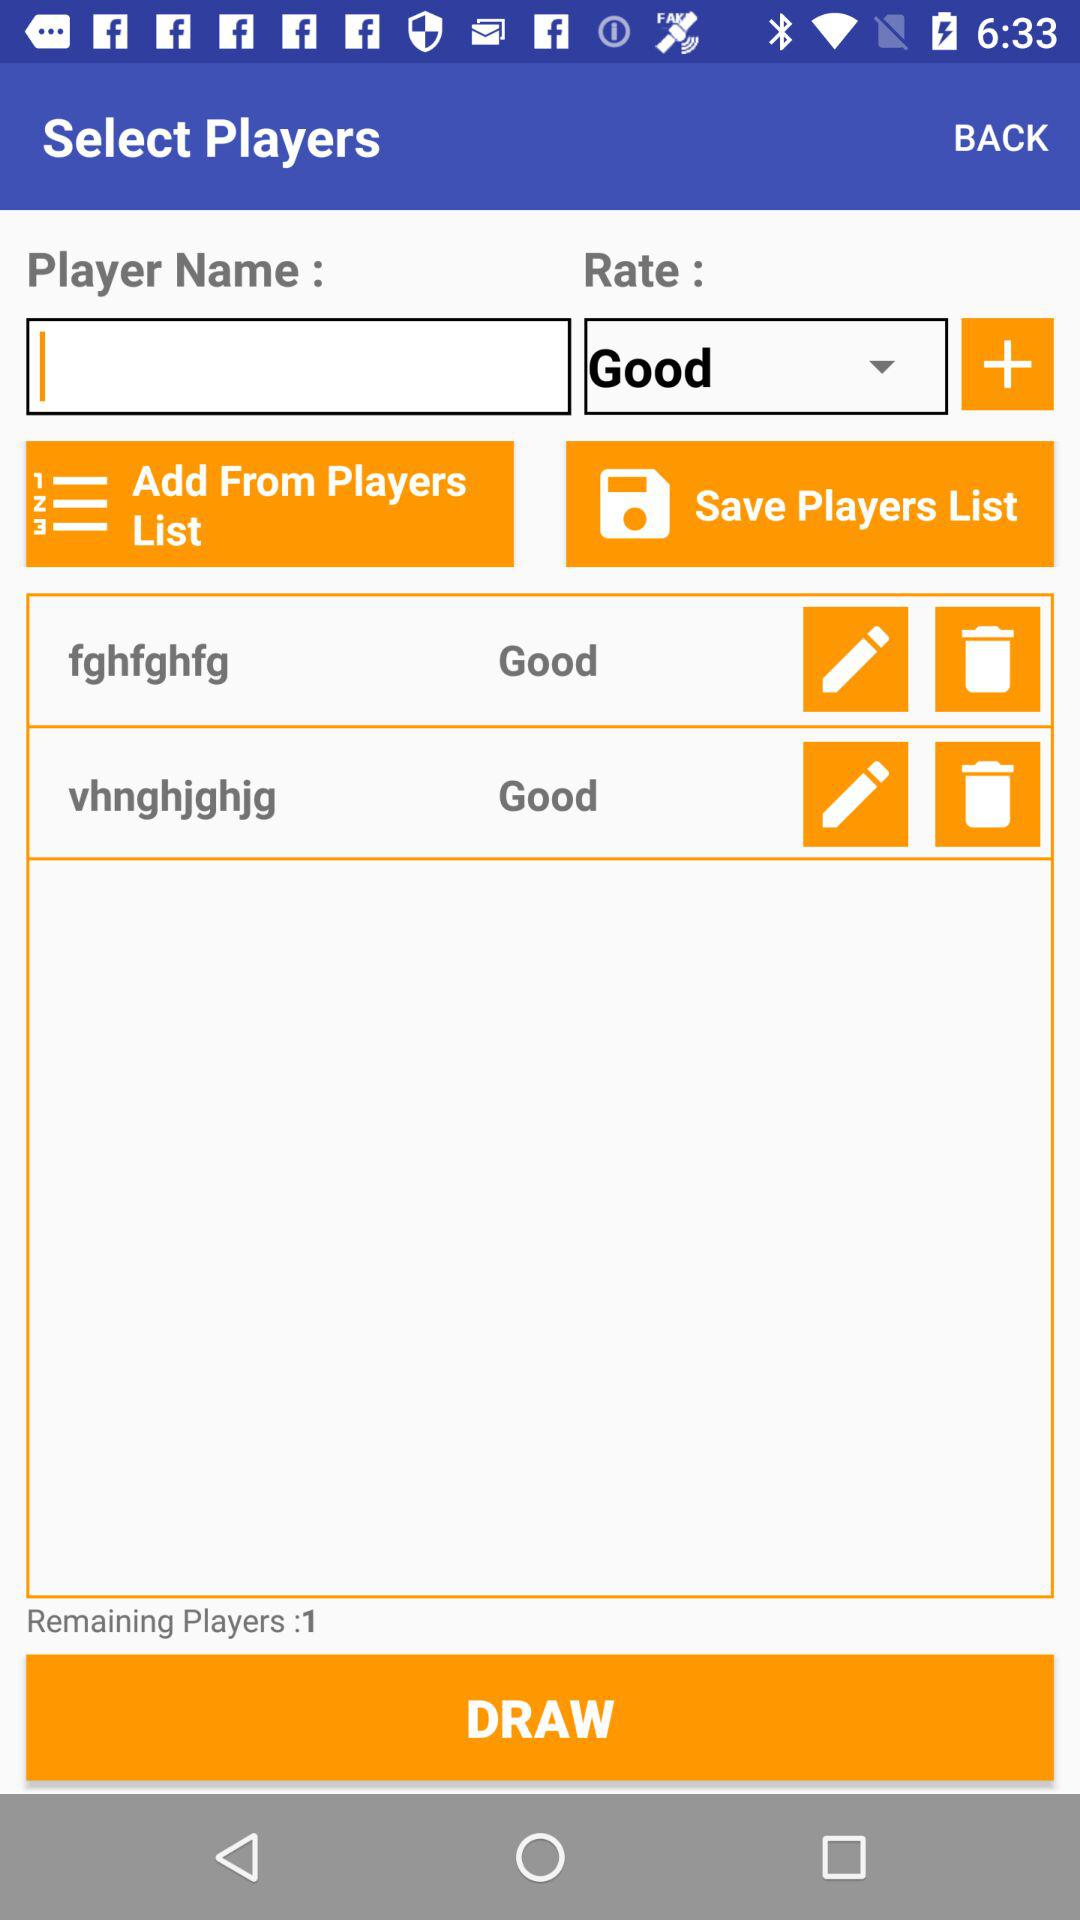How many players have a rating of good?
Answer the question using a single word or phrase. 2 